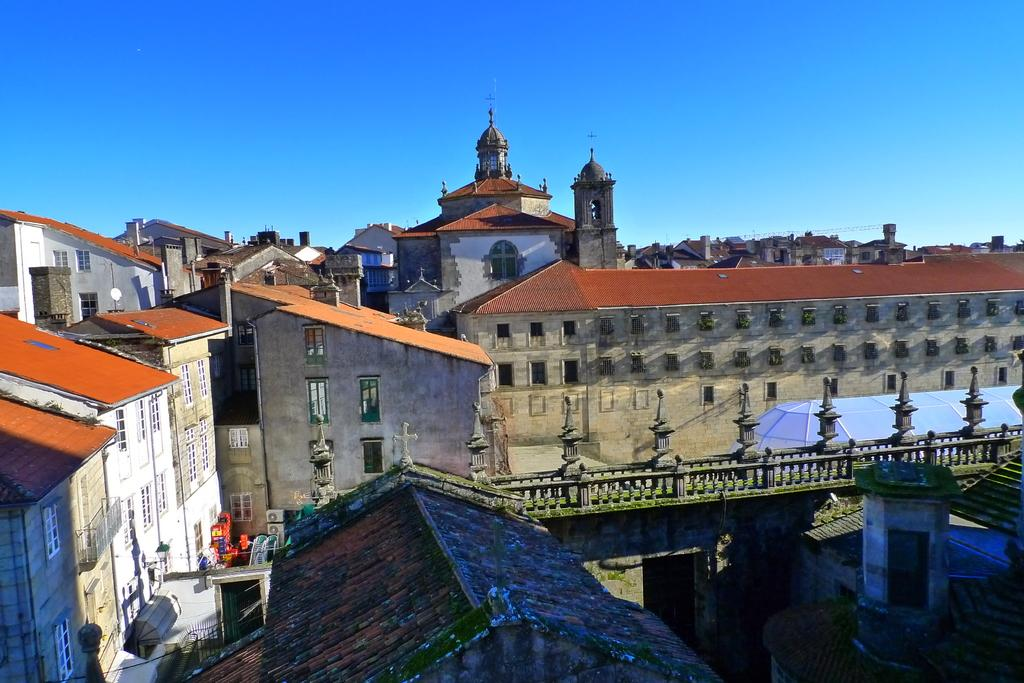What type of structures are visible in the image? There are many buildings with windows in the image. What can be seen on the railings in the image? There are poles on the railings in the image. What is visible in the background of the image? The sky is visible in the background of the image. Can you see any farmers or chickens in the image? No, there are no farmers or chickens present in the image. What type of bun is being used to hold the railings together? There is no bun present in the image; the railings are held together by poles. 